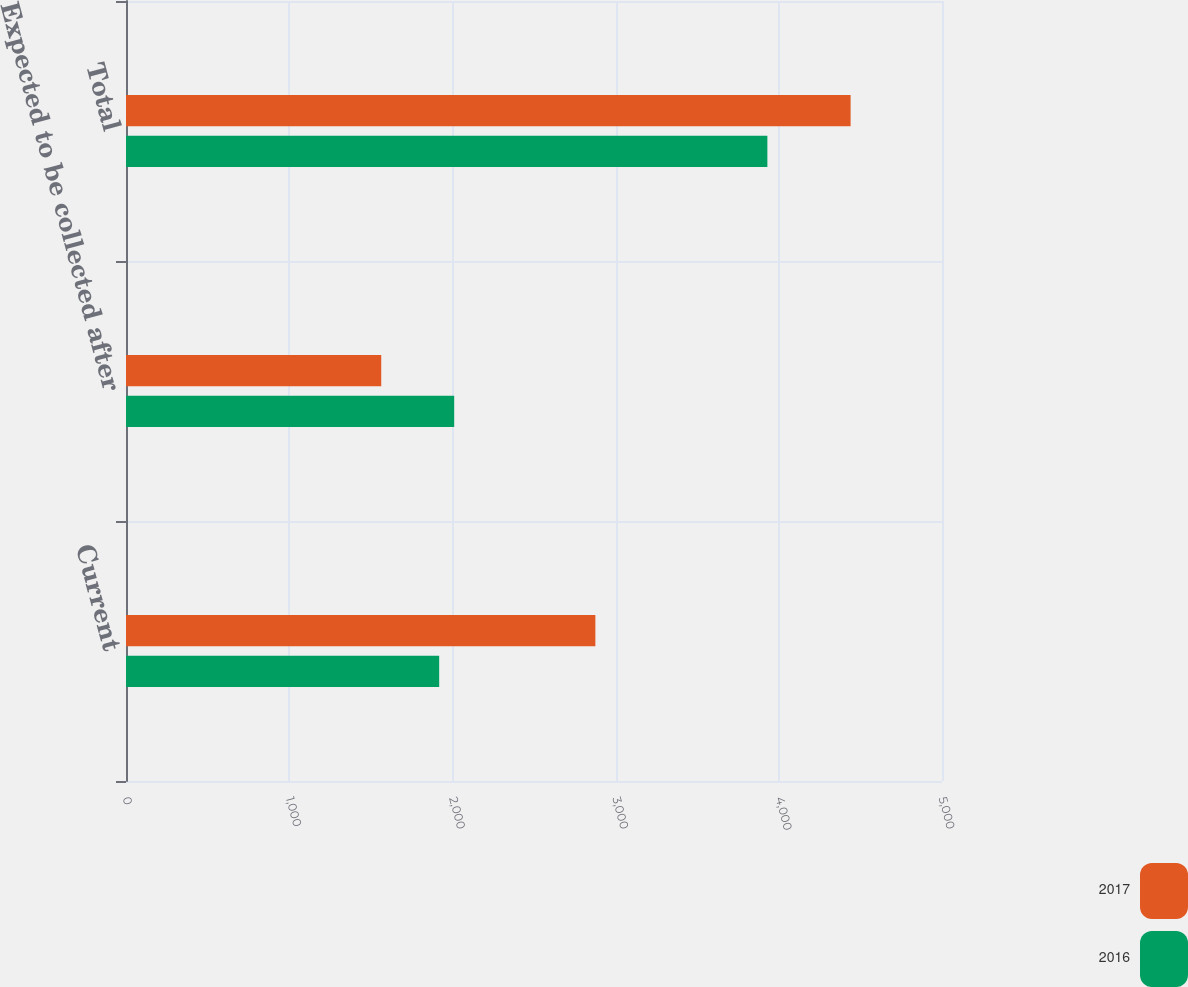<chart> <loc_0><loc_0><loc_500><loc_500><stacked_bar_chart><ecel><fcel>Current<fcel>Expected to be collected after<fcel>Total<nl><fcel>2017<fcel>2876<fcel>1564<fcel>4440<nl><fcel>2016<fcel>1919<fcel>2011<fcel>3930<nl></chart> 